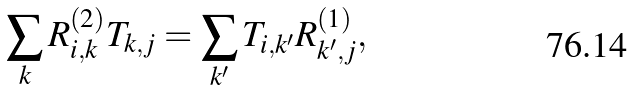Convert formula to latex. <formula><loc_0><loc_0><loc_500><loc_500>\sum _ { k } R ^ { ( 2 ) } _ { i , k } T _ { k , j } = \sum _ { k ^ { \prime } } T _ { i , k ^ { \prime } } R ^ { ( 1 ) } _ { k ^ { \prime } , j } ,</formula> 